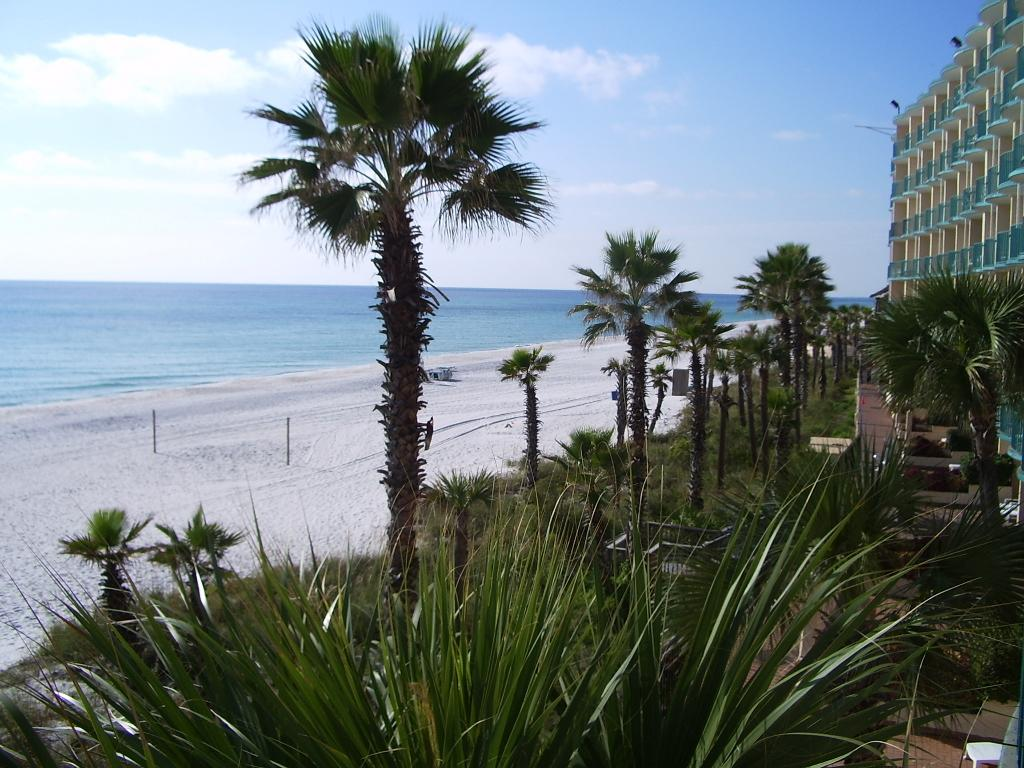What type of natural body of water is visible in the image? There is a sea in the image. What is located near the sea in the image? There is a sea shore in the image. What can be seen in the sky in the image? The sky is visible in the image, with clouds. What type of vegetation is present in the image? There are trees, plants, and grass in the image. What type of man-made surface is present in the image? There is a pavement in the image. What type of structures are present in the image? There are buildings in the image. What type of artificial light source is present in the image? Electric lights are present in the image. How does the dirt affect the mind of the person in the image? There is no person present in the image, and therefore no mind to be affected by dirt. 